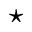Convert formula to latex. <formula><loc_0><loc_0><loc_500><loc_500>^ { * }</formula> 